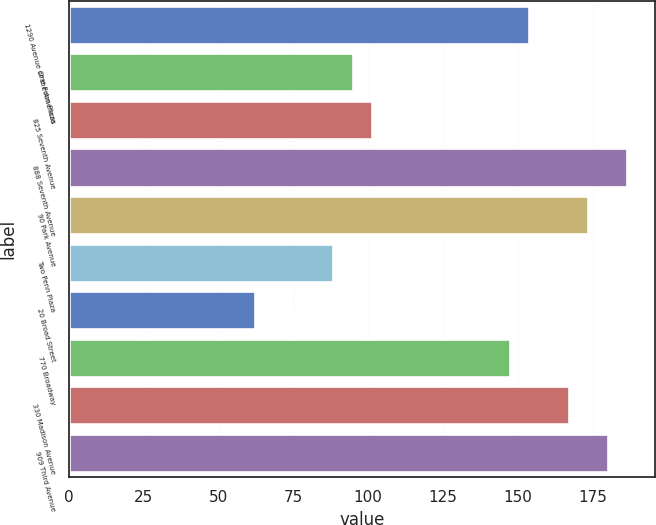Convert chart. <chart><loc_0><loc_0><loc_500><loc_500><bar_chart><fcel>1290 Avenue of the Americas<fcel>One Penn Plaza<fcel>825 Seventh Avenue<fcel>888 Seventh Avenue<fcel>90 Park Avenue<fcel>Two Penn Plaza<fcel>20 Broad Street<fcel>770 Broadway<fcel>330 Madison Avenue<fcel>909 Third Avenue<nl><fcel>153.84<fcel>94.8<fcel>101.36<fcel>186.64<fcel>173.52<fcel>88.24<fcel>62.01<fcel>147.28<fcel>166.96<fcel>180.08<nl></chart> 